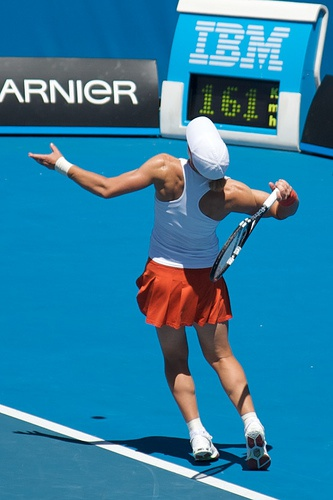Describe the objects in this image and their specific colors. I can see people in blue, black, gray, maroon, and white tones, clock in blue, black, darkgreen, and olive tones, and tennis racket in blue, black, gray, and white tones in this image. 